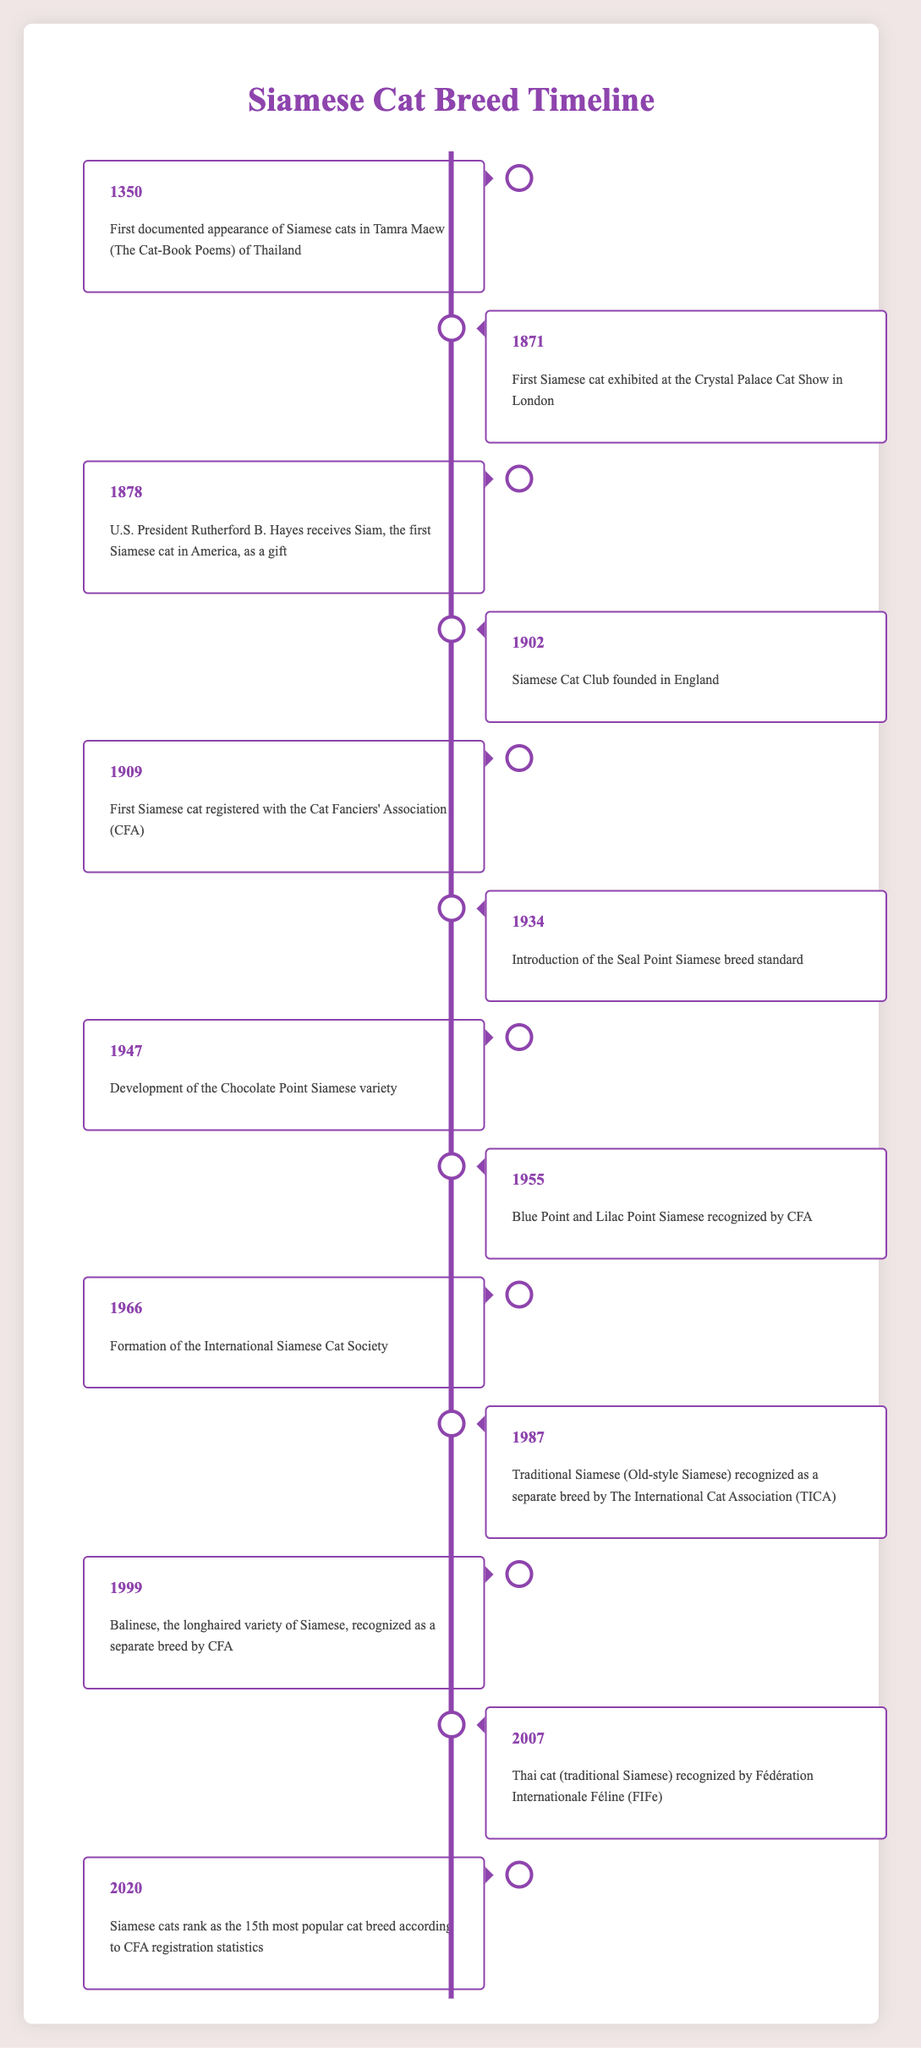What year did the first Siamese cat appear in documented history? The table shows that the first documented appearance of Siamese cats occurred in 1350 in Tamra Maew of Thailand.
Answer: 1350 Who received the first Siamese cat in America? According to the table, U.S. President Rutherford B. Hayes received the first Siamese cat in America as a gift in 1878.
Answer: Rutherford B. Hayes When was the Siamese Cat Club founded? The table indicates that the Siamese Cat Club was founded in England in 1902.
Answer: 1902 What is the time span between the first documented appearance of Siamese cats and the recognition of the Blue Point and Lilac Point Siamese by CFA? The first documented appearance was in 1350 and the recognition of the Blue Point and Lilac Point Siamese by CFA occurred in 1955. The time span is 1955 - 1350 = 605 years.
Answer: 605 years Is it true that the first Siamese cat was exhibited at the Crystal Palace Cat Show? The table confirms that the first Siamese cat was indeed exhibited at the Crystal Palace Cat Show in London in 1871, confirming the statement as true.
Answer: Yes Which event in the table occurred last, and what year was it? The last event listed in the table is from 2020, stating that Siamese cats ranked as the 15th most popular cat breed according to CFA registration statistics.
Answer: 2020 Was the first Siamese cat registered with the Cat Fanciers' Association (CFA) before or after the introduction of the Seal Point Siamese breed standard? The first Siamese cat was registered with the CFA in 1909 and the Seal Point Siamese breed standard was introduced in 1934. Since 1909 is before 1934, the answer is before.
Answer: Before How many years elapsed between the development of the Chocolate Point Siamese variety and the recognition of the Balinese as a separate breed by CFA? The Chocolate Point Siamese was developed in 1947 and the Balinese was recognized in 1999. The time elapsed is 1999 - 1947 = 52 years.
Answer: 52 years What significant recognition occurred related to Traditional Siamese in 1987? The table indicates that in 1987, Traditional Siamese (Old-style Siamese) was recognized as a separate breed by The International Cat Association (TICA).
Answer: Recognized as a separate breed 